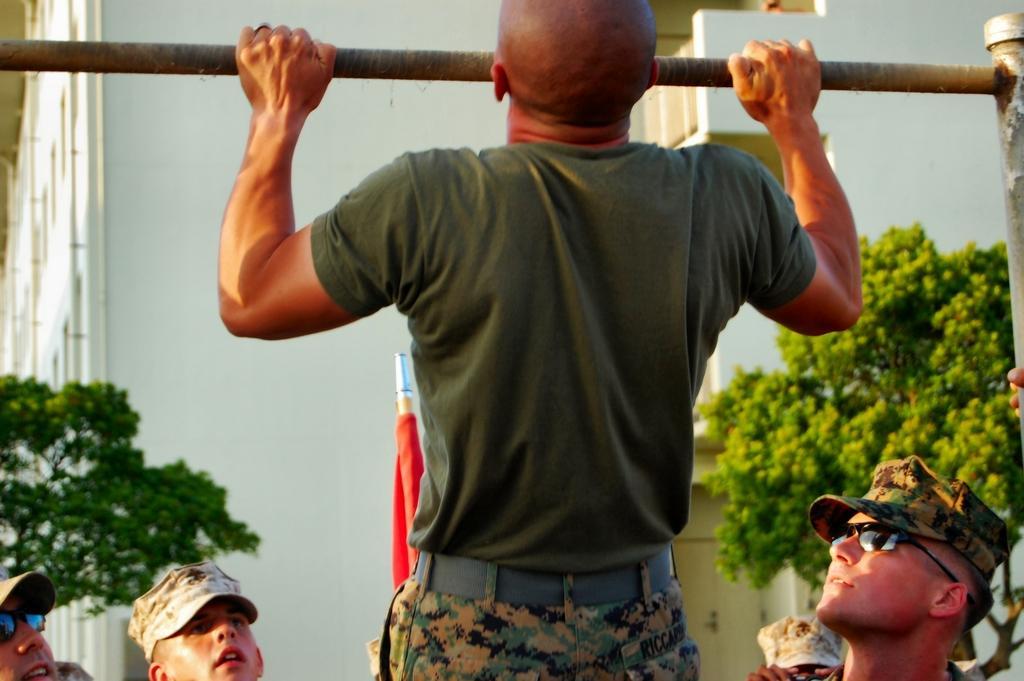How would you summarize this image in a sentence or two? In this image, we can see a man holding a metal rod. In the background, we can see some plants, buildings. At the bottom, we can see a group of people. 